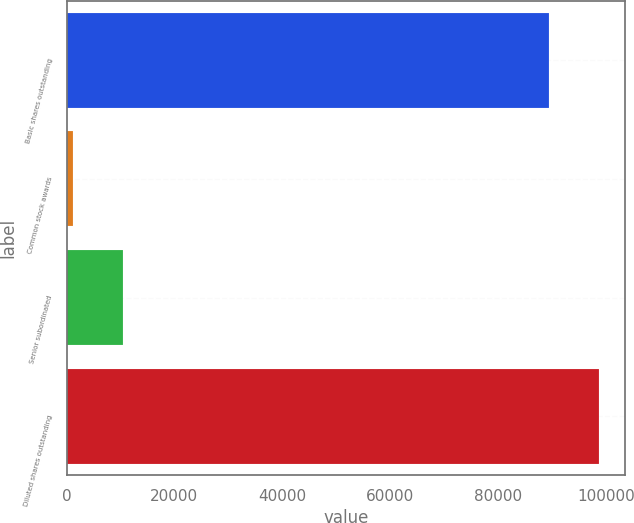Convert chart to OTSL. <chart><loc_0><loc_0><loc_500><loc_500><bar_chart><fcel>Basic shares outstanding<fcel>Common stock awards<fcel>Senior subordinated<fcel>Diluted shares outstanding<nl><fcel>89468<fcel>1155<fcel>10409.4<fcel>98722.4<nl></chart> 